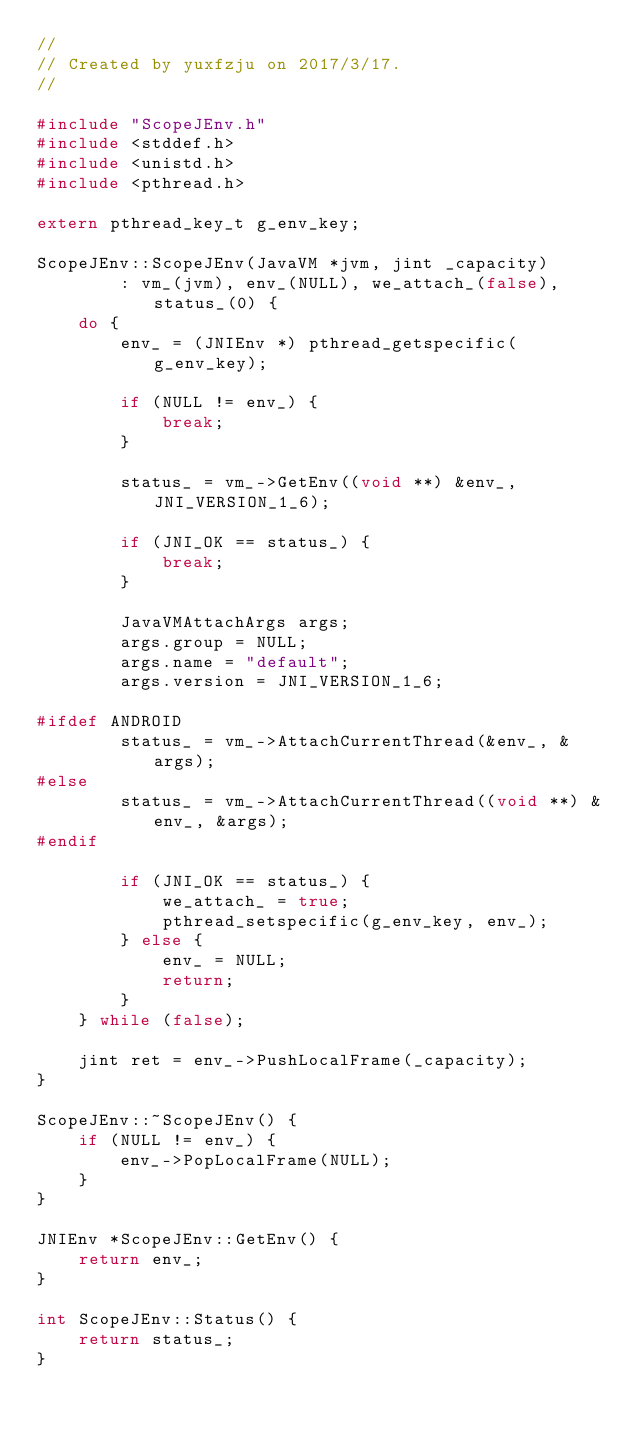Convert code to text. <code><loc_0><loc_0><loc_500><loc_500><_C++_>//
// Created by yuxfzju on 2017/3/17.
//

#include "ScopeJEnv.h"
#include <stddef.h>
#include <unistd.h>
#include <pthread.h>

extern pthread_key_t g_env_key;

ScopeJEnv::ScopeJEnv(JavaVM *jvm, jint _capacity)
        : vm_(jvm), env_(NULL), we_attach_(false), status_(0) {
    do {
        env_ = (JNIEnv *) pthread_getspecific(g_env_key);

        if (NULL != env_) {
            break;
        }

        status_ = vm_->GetEnv((void **) &env_, JNI_VERSION_1_6);

        if (JNI_OK == status_) {
            break;
        }

        JavaVMAttachArgs args;
        args.group = NULL;
        args.name = "default";
        args.version = JNI_VERSION_1_6;

#ifdef ANDROID
        status_ = vm_->AttachCurrentThread(&env_, &args);
#else
        status_ = vm_->AttachCurrentThread((void **) &env_, &args);
#endif

        if (JNI_OK == status_) {
            we_attach_ = true;
            pthread_setspecific(g_env_key, env_);
        } else {
            env_ = NULL;
            return;
        }
    } while (false);

    jint ret = env_->PushLocalFrame(_capacity);
}

ScopeJEnv::~ScopeJEnv() {
    if (NULL != env_) {
        env_->PopLocalFrame(NULL);
    }
}

JNIEnv *ScopeJEnv::GetEnv() {
    return env_;
}

int ScopeJEnv::Status() {
    return status_;
}</code> 